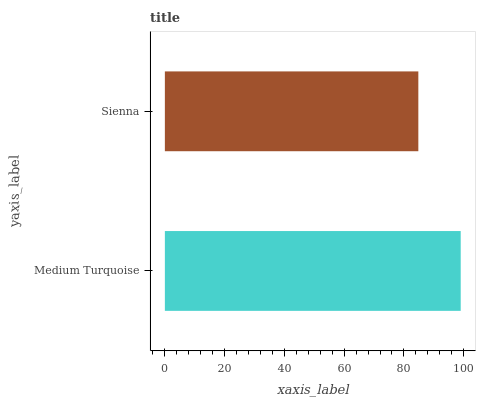Is Sienna the minimum?
Answer yes or no. Yes. Is Medium Turquoise the maximum?
Answer yes or no. Yes. Is Sienna the maximum?
Answer yes or no. No. Is Medium Turquoise greater than Sienna?
Answer yes or no. Yes. Is Sienna less than Medium Turquoise?
Answer yes or no. Yes. Is Sienna greater than Medium Turquoise?
Answer yes or no. No. Is Medium Turquoise less than Sienna?
Answer yes or no. No. Is Medium Turquoise the high median?
Answer yes or no. Yes. Is Sienna the low median?
Answer yes or no. Yes. Is Sienna the high median?
Answer yes or no. No. Is Medium Turquoise the low median?
Answer yes or no. No. 